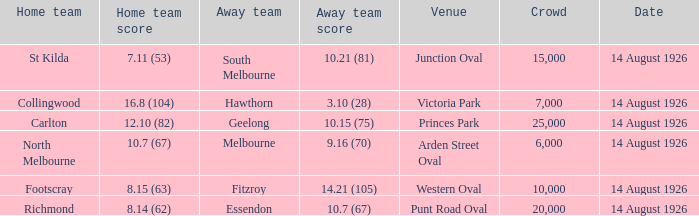Write the full table. {'header': ['Home team', 'Home team score', 'Away team', 'Away team score', 'Venue', 'Crowd', 'Date'], 'rows': [['St Kilda', '7.11 (53)', 'South Melbourne', '10.21 (81)', 'Junction Oval', '15,000', '14 August 1926'], ['Collingwood', '16.8 (104)', 'Hawthorn', '3.10 (28)', 'Victoria Park', '7,000', '14 August 1926'], ['Carlton', '12.10 (82)', 'Geelong', '10.15 (75)', 'Princes Park', '25,000', '14 August 1926'], ['North Melbourne', '10.7 (67)', 'Melbourne', '9.16 (70)', 'Arden Street Oval', '6,000', '14 August 1926'], ['Footscray', '8.15 (63)', 'Fitzroy', '14.21 (105)', 'Western Oval', '10,000', '14 August 1926'], ['Richmond', '8.14 (62)', 'Essendon', '10.7 (67)', 'Punt Road Oval', '20,000', '14 August 1926']]} What was the smallest crowd that watched an away team score 3.10 (28)? 7000.0. 